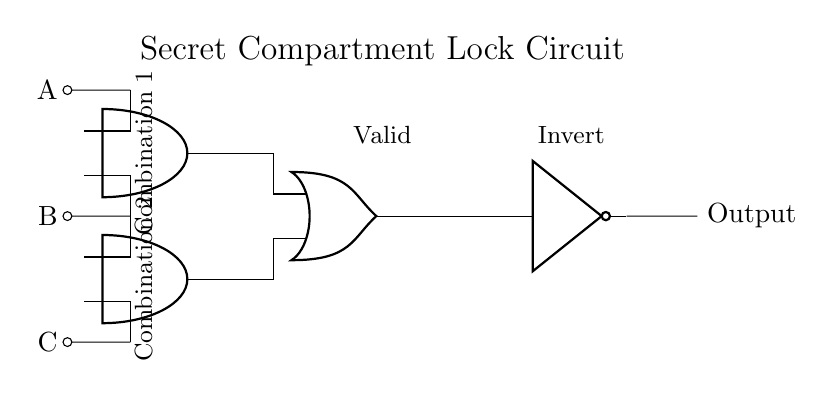What is the output type of this circuit? The output of the circuit is connected to a NOT gate, meaning the final output is inverted from the result of the OR gate. The configuration shows that it produces a low signal when the conditions are met.
Answer: Inverted What are the number of inputs to this circuit? The circuit has three inputs labeled A, B, and C, which are essential for its operation. The inputs represent different activation conditions for unlocking the compartment.
Answer: Three Which logic gate combines the results of the two AND gates? The OR gate combines the outputs from the two AND gates, indicating that at least one of the AND gates needs to output a high signal for the result going into the NOT gate.
Answer: OR gate What must both conditions in Combination 1 be for a high output? In Combination 1, both A and B must be high to achieve a high output from the first AND gate, as both inputs must be active for an AND gate.
Answer: A and B How many AND gates are present in the circuit? There are two AND gates in the circuit, each processing combinations of inputs to determine if the lock should be activated based on input conditions.
Answer: Two What will happen if all inputs A, B, and C are low? If inputs A, B, and C are all low, both AND gates will output low, resulting in the OR gate also outputting low, and thus the NOT gate will produce a high signal. The compartment remains locked.
Answer: High output 